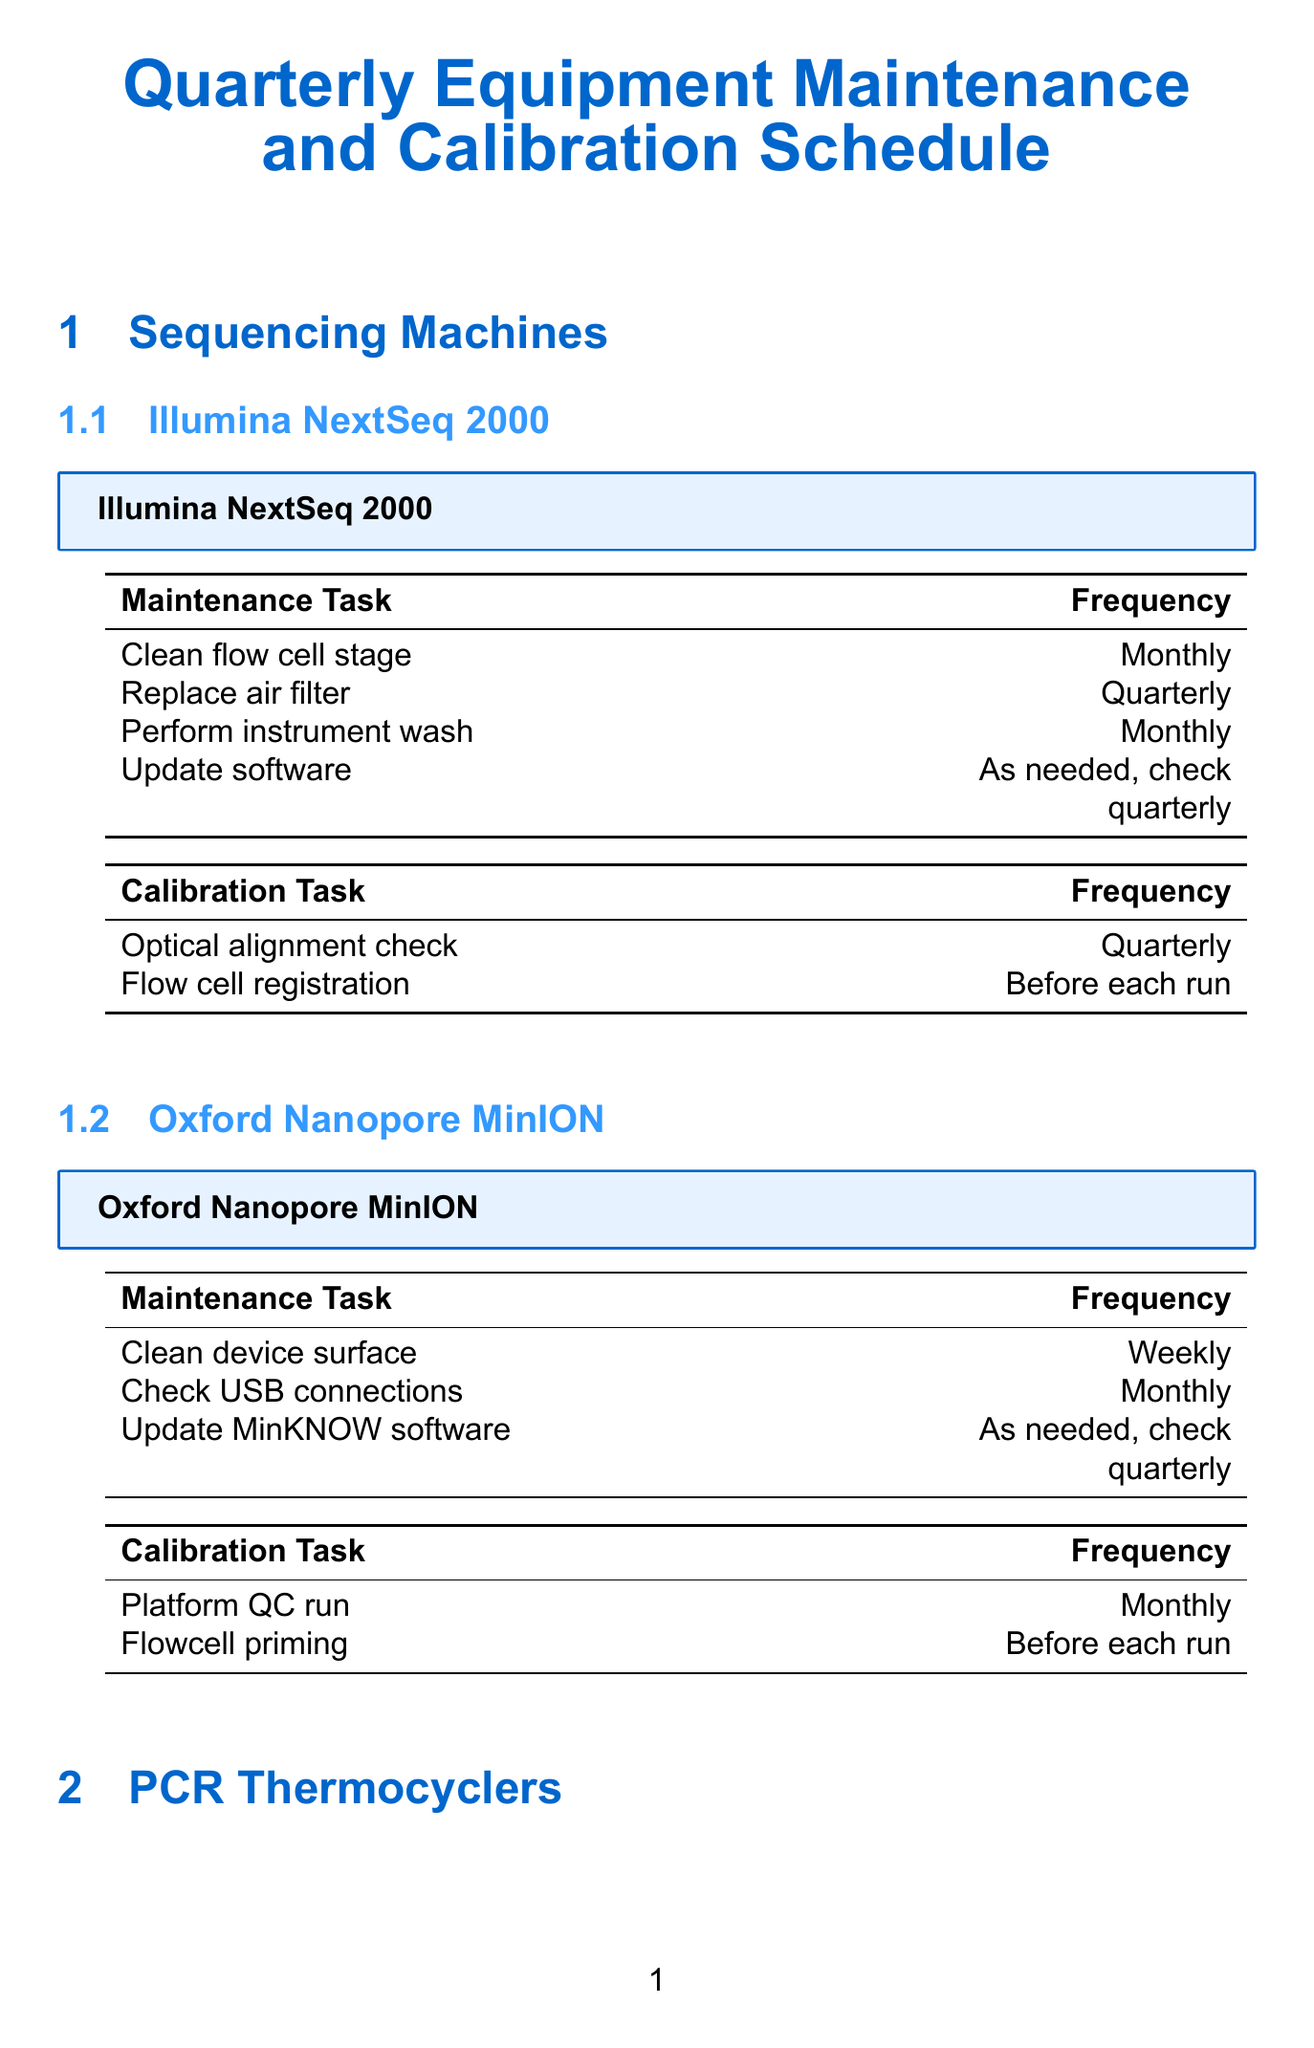What is the maintenance task for the Illumina NextSeq 2000? The maintenance tasks listed for the Illumina NextSeq 2000 in the document include cleaning the flow cell stage, replacing the air filter, performing an instrument wash, and updating the software.
Answer: Clean flow cell stage What is the frequency of cleaning the optical lenses for the Bio-Rad CFX96 Touch? The document states that the cleaning of optical lenses is a monthly task for the Bio-Rad CFX96 Touch.
Answer: Monthly How many calibration tasks does the Applied Biosystems QuantStudio 5 have? By counting the number of calibration tasks listed in the Applied Biosystems QuantStudio 5 section, including background calibration, uniformity test, and optical calibration, we find that there are three tasks.
Answer: Three What is the frequency of updating the MinKNOW software for the Oxford Nanopore MinION? The document mentions that updating the MinKNOW software is done as needed, with a check suggested quarterly.
Answer: As needed, check quarterly Which sequencing machine requires flow cell registration before each run? The document specifies that the flow cell registration task is required before each run for the Illumina NextSeq 2000.
Answer: Illumina NextSeq 2000 How often should tube compression pads be checked and replaced for the Applied Biosystems QuantStudio 5? The schedule indicates that tube compression pads should be checked and replaced quarterly for the Applied Biosystems QuantStudio 5.
Answer: Quarterly 